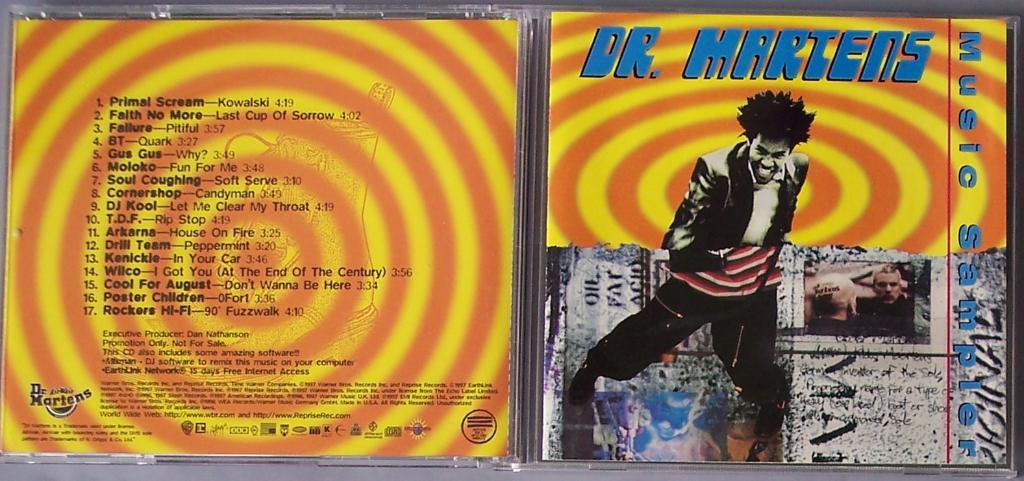Provide a one-sentence caption for the provided image. A plastic Dr. Martens cd cover is opened showing concentric orange and yellow circles. 